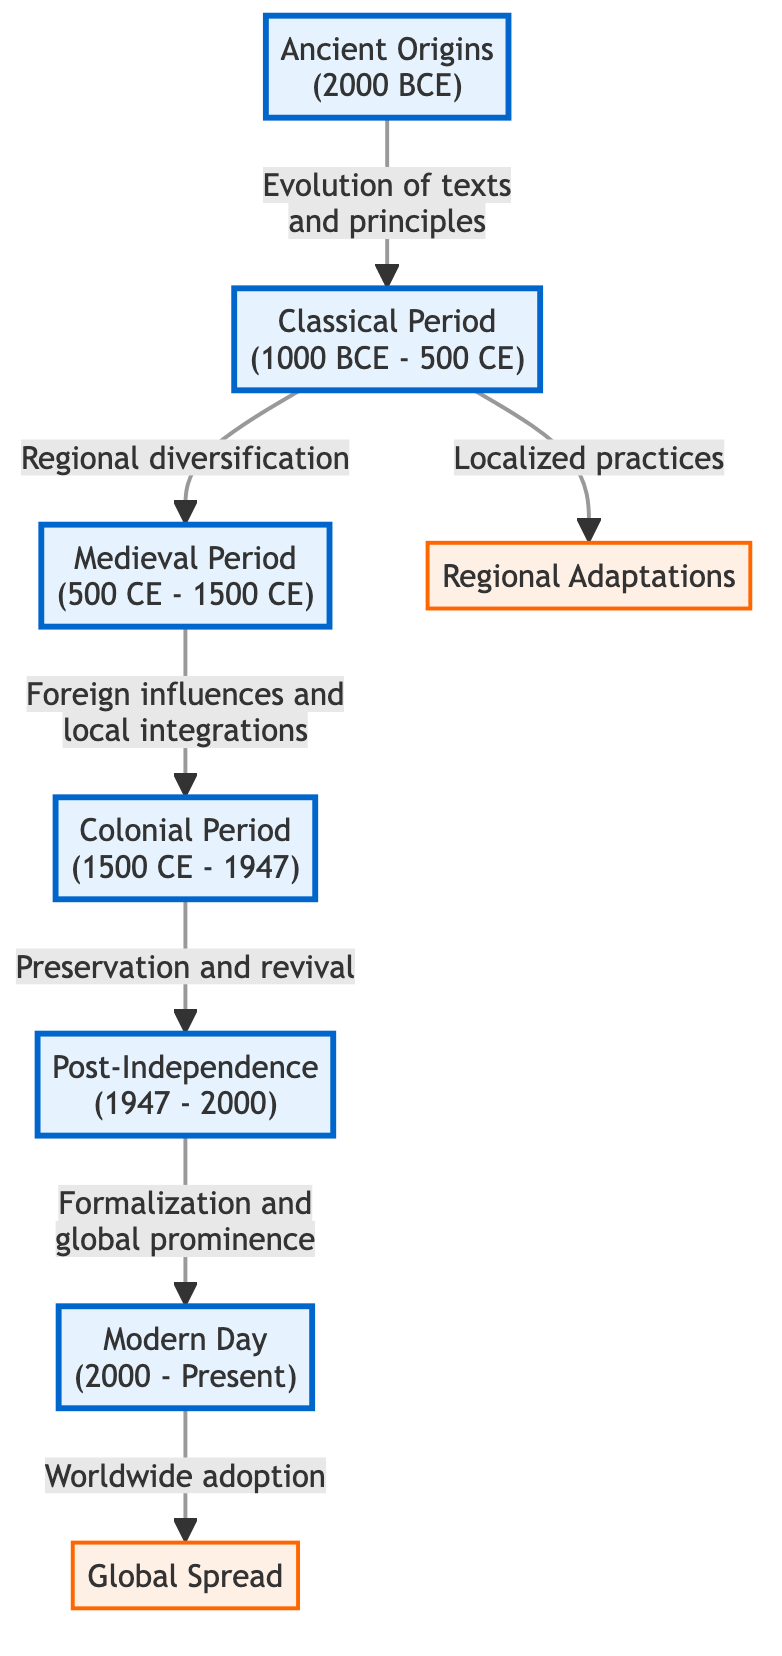What period does the diagram identify as the "Classical Period"? The diagram clearly states the 'Classical Period' as between 1000 BCE and 500 CE. This information is directly visible within the timeline section of the diagram.
Answer: 1000 BCE - 500 CE Which two major adaptations are highlighted in the diagram? The diagram specifically categorizes 'Regional Adaptations' and 'Global Spread' as two significant adaptations associated with the evolution of Ayurvedic practices. These categories are visually distinct in the adaptation section of the diagram.
Answer: Regional Adaptations, Global Spread How many distinct periods are shown in the timeline? By counting the different nodes labeled within the timeline, we see six distinct periods identified: Ancient Origins, Classical Period, Medieval Period, Colonial Period, Post-Independence, and Modern Day.
Answer: 6 What is the main influence during the Medieval Period according to the diagram? The diagram illustrates that the Medieval Period's main influence comprises 'Foreign influences and local integrations.' This information links the Medieval Period to the Colonial Period in the flow of the diagram.
Answer: Foreign influences and local integrations In which period did 'Preservation and revival' occur? The diagram directly marks 'Preservation and revival' as an influential aspect occurring during the 'Post-Independence' period, establishing a clear timeline connection.
Answer: Post-Independence What initiated the transition between 'Ancient Origins' and the 'Classical Period'? The transition from 'Ancient Origins' to 'Classical Period' is catalyzed by the 'Evolution of texts and principles,' as described in the relationship indicated in the diagram.
Answer: Evolution of texts and principles What characteristic is associated with the practices in the 'Classical Period'? According to the diagram, the 'Classical Period' is associated with 'Regional diversification,' which points to an expanding variety of practices influenced by local traditions.
Answer: Regional diversification Which period marks the beginning of the modern global prominence of Ayurveda? The 'Post-Independence' period is identified in the diagram as the beginning of Ayurveda's 'Formalization and global prominence,' clearly connecting it to the modern evolution of the practice.
Answer: Post-Independence 